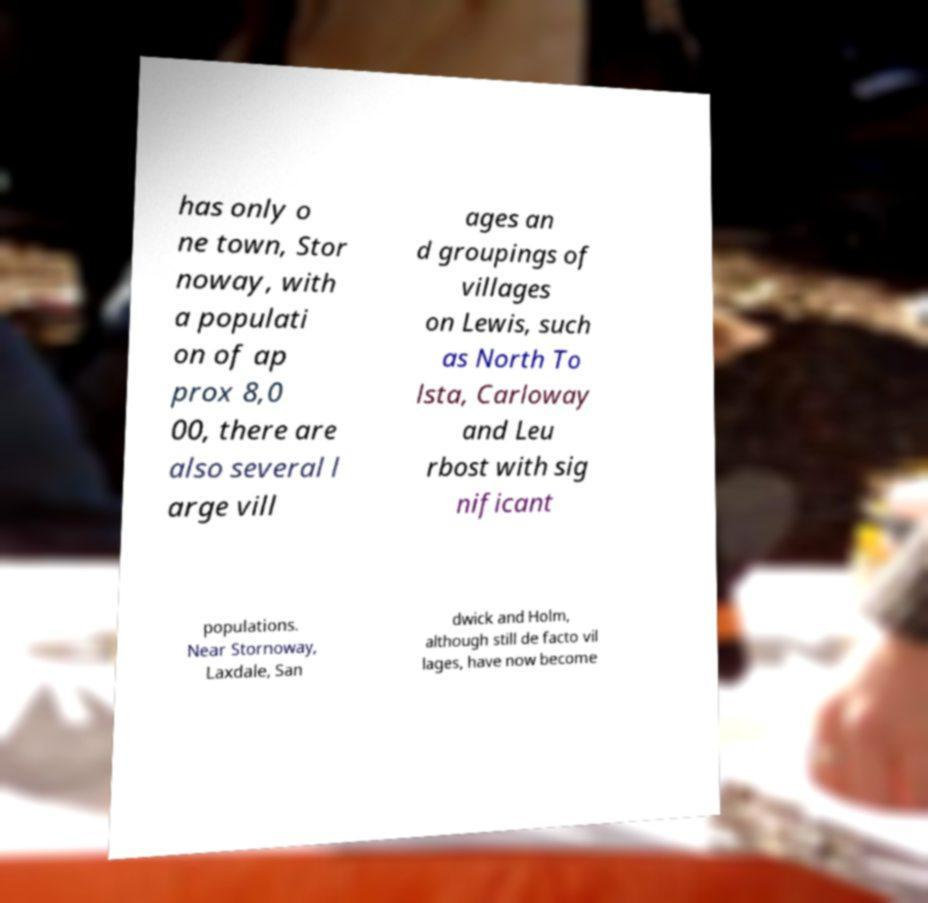What messages or text are displayed in this image? I need them in a readable, typed format. has only o ne town, Stor noway, with a populati on of ap prox 8,0 00, there are also several l arge vill ages an d groupings of villages on Lewis, such as North To lsta, Carloway and Leu rbost with sig nificant populations. Near Stornoway, Laxdale, San dwick and Holm, although still de facto vil lages, have now become 